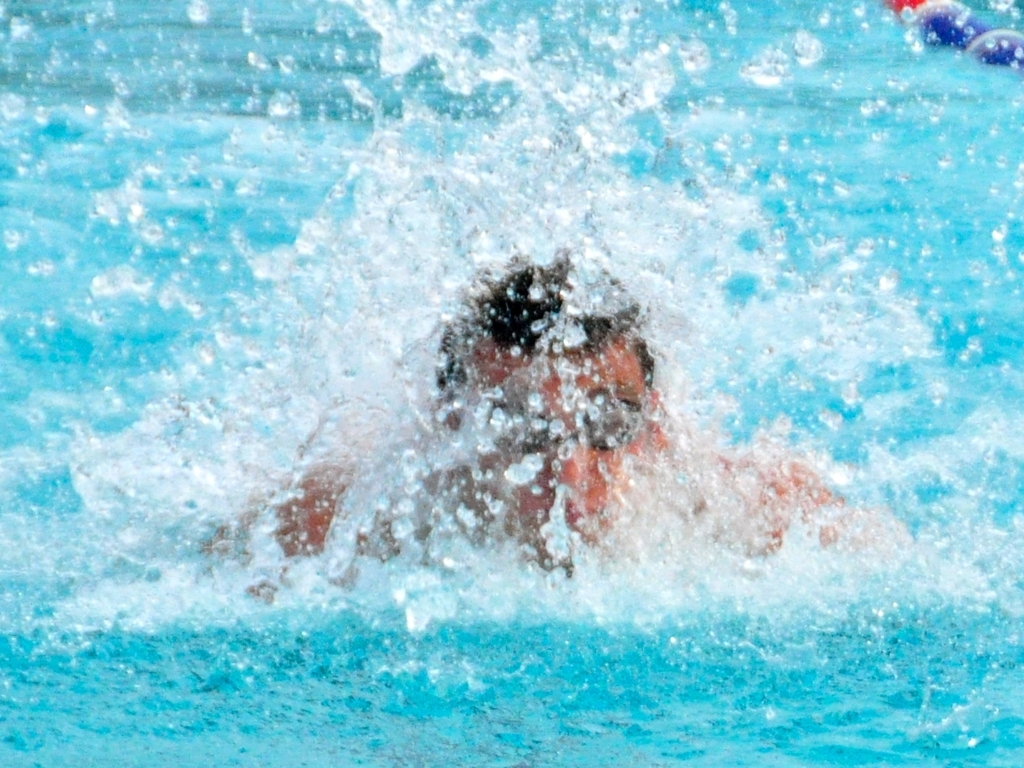What kind of swimming stroke might the athlete be performing? While the image is mostly obscured by the splash, it could suggest that the athlete is either starting a race with a dive into the pool or is in the midst of a powerful stroke such as the butterfly or freestyle given the magnitude of the splash. 